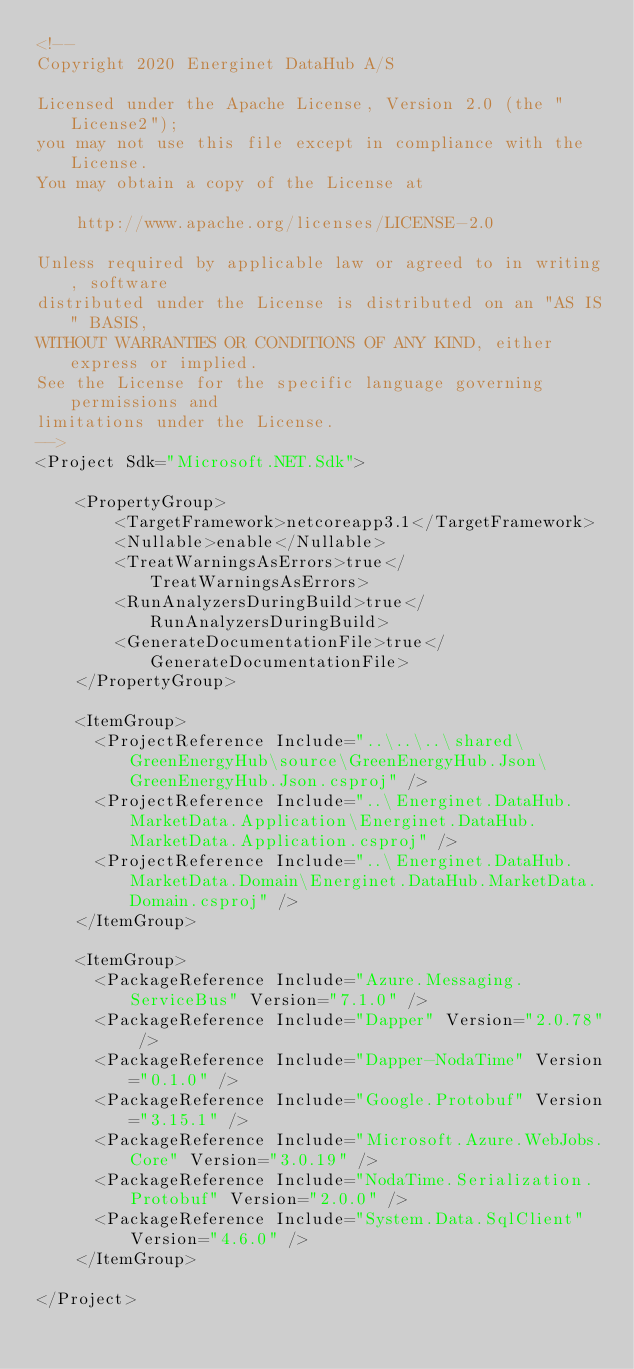<code> <loc_0><loc_0><loc_500><loc_500><_XML_><!--
Copyright 2020 Energinet DataHub A/S

Licensed under the Apache License, Version 2.0 (the "License2");
you may not use this file except in compliance with the License.
You may obtain a copy of the License at

    http://www.apache.org/licenses/LICENSE-2.0

Unless required by applicable law or agreed to in writing, software
distributed under the License is distributed on an "AS IS" BASIS,
WITHOUT WARRANTIES OR CONDITIONS OF ANY KIND, either express or implied.
See the License for the specific language governing permissions and
limitations under the License.
-->
<Project Sdk="Microsoft.NET.Sdk">

    <PropertyGroup>
        <TargetFramework>netcoreapp3.1</TargetFramework>
        <Nullable>enable</Nullable>
        <TreatWarningsAsErrors>true</TreatWarningsAsErrors>
        <RunAnalyzersDuringBuild>true</RunAnalyzersDuringBuild>
        <GenerateDocumentationFile>true</GenerateDocumentationFile>
    </PropertyGroup>

    <ItemGroup>
      <ProjectReference Include="..\..\..\shared\GreenEnergyHub\source\GreenEnergyHub.Json\GreenEnergyHub.Json.csproj" />
      <ProjectReference Include="..\Energinet.DataHub.MarketData.Application\Energinet.DataHub.MarketData.Application.csproj" />
      <ProjectReference Include="..\Energinet.DataHub.MarketData.Domain\Energinet.DataHub.MarketData.Domain.csproj" />
    </ItemGroup>

    <ItemGroup>
      <PackageReference Include="Azure.Messaging.ServiceBus" Version="7.1.0" />
      <PackageReference Include="Dapper" Version="2.0.78" />
      <PackageReference Include="Dapper-NodaTime" Version="0.1.0" />
      <PackageReference Include="Google.Protobuf" Version="3.15.1" />
      <PackageReference Include="Microsoft.Azure.WebJobs.Core" Version="3.0.19" />
      <PackageReference Include="NodaTime.Serialization.Protobuf" Version="2.0.0" />
      <PackageReference Include="System.Data.SqlClient" Version="4.6.0" />
    </ItemGroup>

</Project>
</code> 